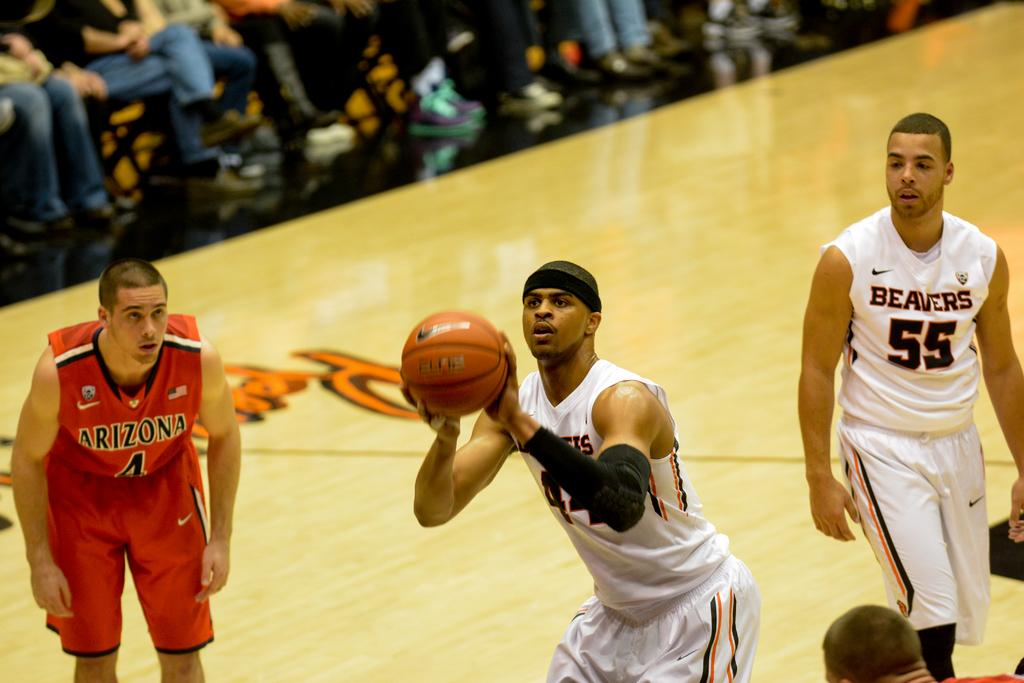<image>
Summarize the visual content of the image. Men playing basketball, one with a Beavers shirt on. 